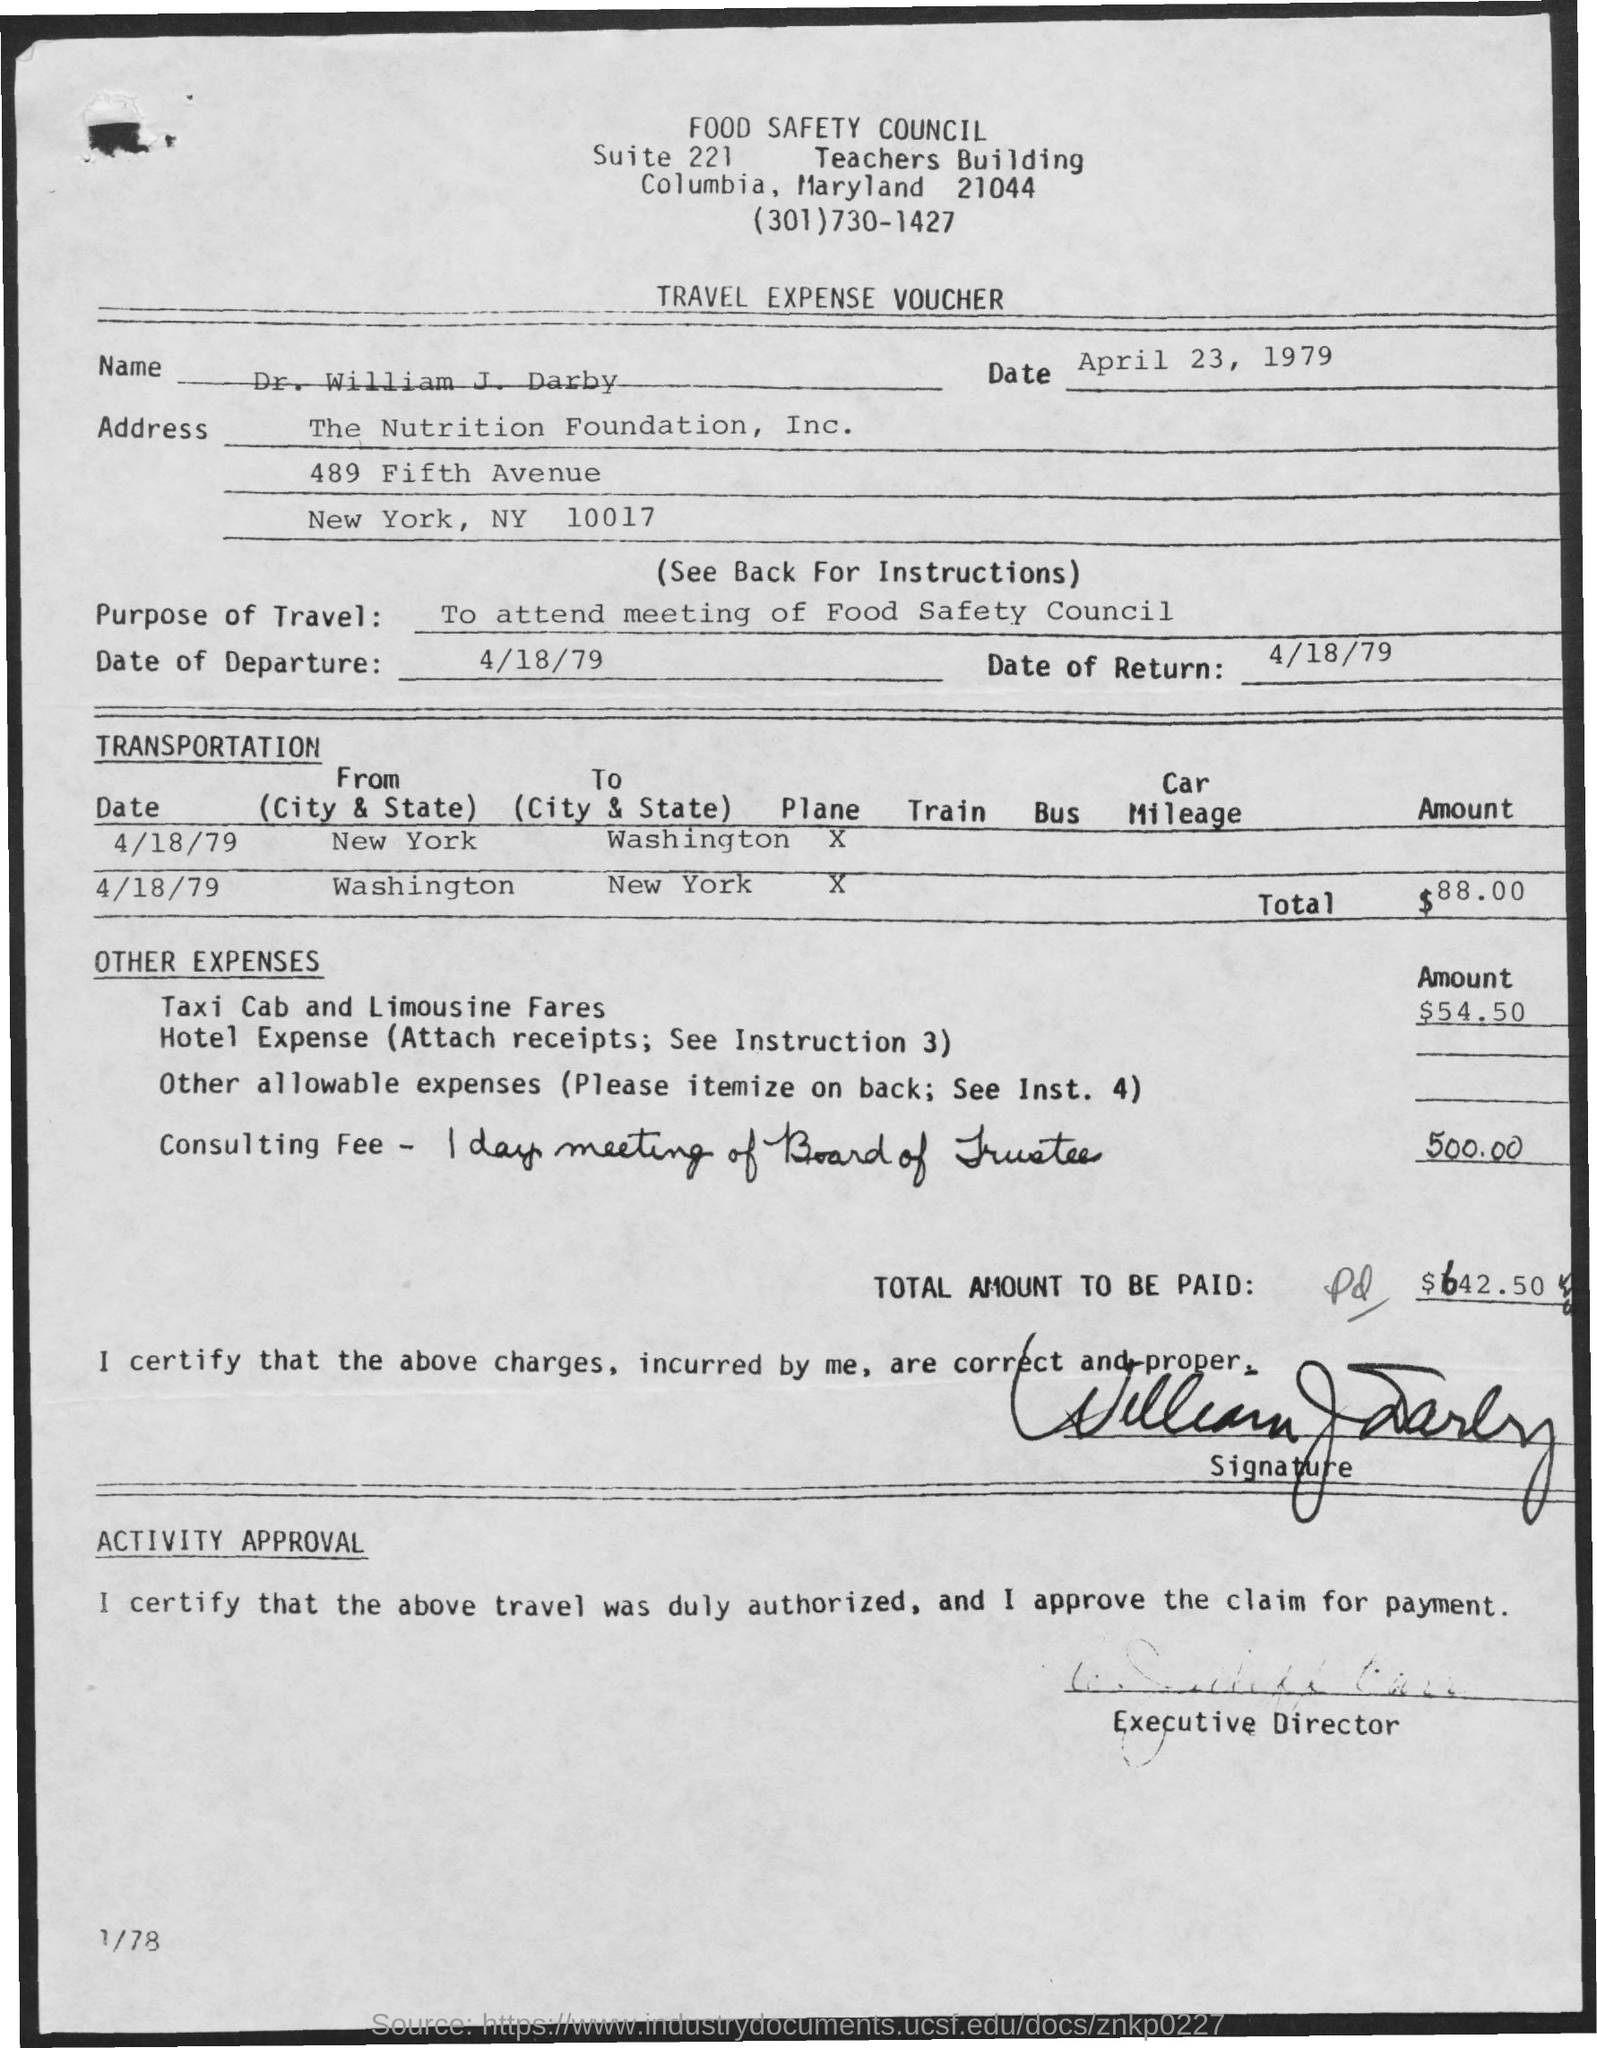List a handful of essential elements in this visual. The date of departure is April 18, 1979. The Travel Expense Voucher is a type of voucher. The date mentioned at the top of the document is April 23, 1979. The return date is April 18, 1979. The top of the document reads "Food Safety Council. 